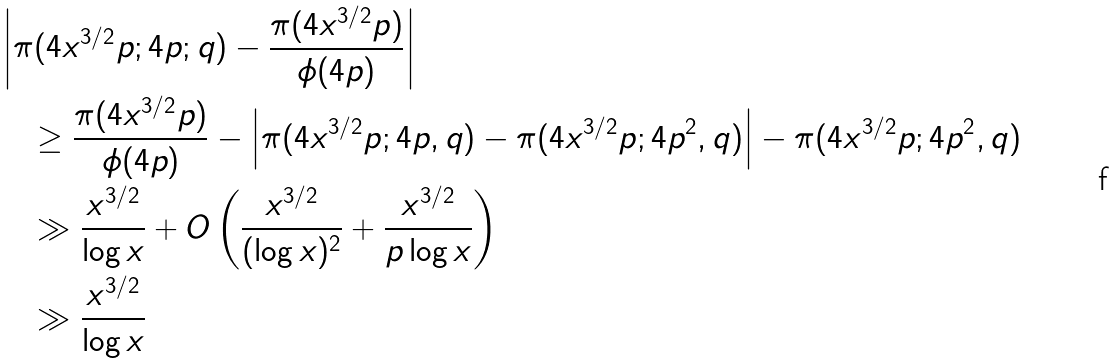Convert formula to latex. <formula><loc_0><loc_0><loc_500><loc_500>& \left | \pi ( 4 x ^ { 3 / 2 } p ; 4 p ; q ) - \frac { \pi ( 4 x ^ { 3 / 2 } p ) } { \phi ( 4 p ) } \right | \\ & \quad \geq \frac { \pi ( 4 x ^ { 3 / 2 } p ) } { \phi ( 4 p ) } - \left | \pi ( 4 x ^ { 3 / 2 } p ; 4 p , q ) - \pi ( 4 x ^ { 3 / 2 } p ; 4 p ^ { 2 } , q ) \right | - \pi ( 4 x ^ { 3 / 2 } p ; 4 p ^ { 2 } , q ) \\ & \quad \gg \frac { x ^ { 3 / 2 } } { \log x } + O \left ( \frac { x ^ { 3 / 2 } } { ( \log x ) ^ { 2 } } + \frac { x ^ { 3 / 2 } } { p \log x } \right ) \\ & \quad \gg \frac { x ^ { 3 / 2 } } { \log x }</formula> 